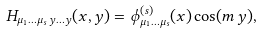<formula> <loc_0><loc_0><loc_500><loc_500>H _ { \mu _ { 1 } \dots \mu _ { s } \, y \dots y } ( x , y ) = \phi ^ { ( s ) } _ { \mu _ { 1 } \dots \mu _ { s } } ( x ) \cos ( m \, y ) ,</formula> 